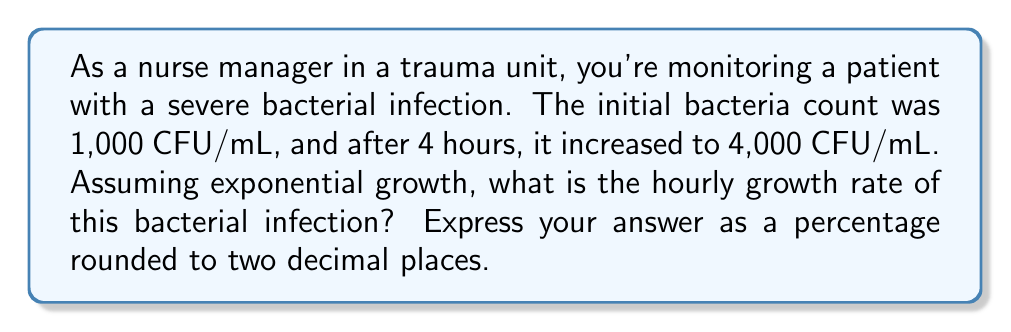Give your solution to this math problem. Let's approach this step-by-step using the exponential growth formula:

1) The exponential growth formula is:
   $A = P(1 + r)^t$
   Where:
   $A$ = Final amount
   $P$ = Initial amount
   $r$ = Growth rate (in decimal form)
   $t$ = Time

2) We know:
   $P = 1,000$ CFU/mL
   $A = 4,000$ CFU/mL
   $t = 4$ hours

3) Let's plug these into our formula:
   $4,000 = 1,000(1 + r)^4$

4) Divide both sides by 1,000:
   $4 = (1 + r)^4$

5) Take the fourth root of both sides:
   $\sqrt[4]{4} = 1 + r$

6) Simplify:
   $1.4142 = 1 + r$

7) Subtract 1 from both sides:
   $0.4142 = r$

8) Convert to a percentage by multiplying by 100:
   $41.42\%$

Therefore, the hourly growth rate is approximately 41.42%.
Answer: $41.42\%$ 